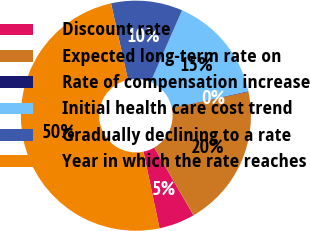Convert chart to OTSL. <chart><loc_0><loc_0><loc_500><loc_500><pie_chart><fcel>Discount rate<fcel>Expected long-term rate on<fcel>Rate of compensation increase<fcel>Initial health care cost trend<fcel>Gradually declining to a rate<fcel>Year in which the rate reaches<nl><fcel>5.06%<fcel>19.98%<fcel>0.09%<fcel>15.01%<fcel>10.04%<fcel>49.82%<nl></chart> 